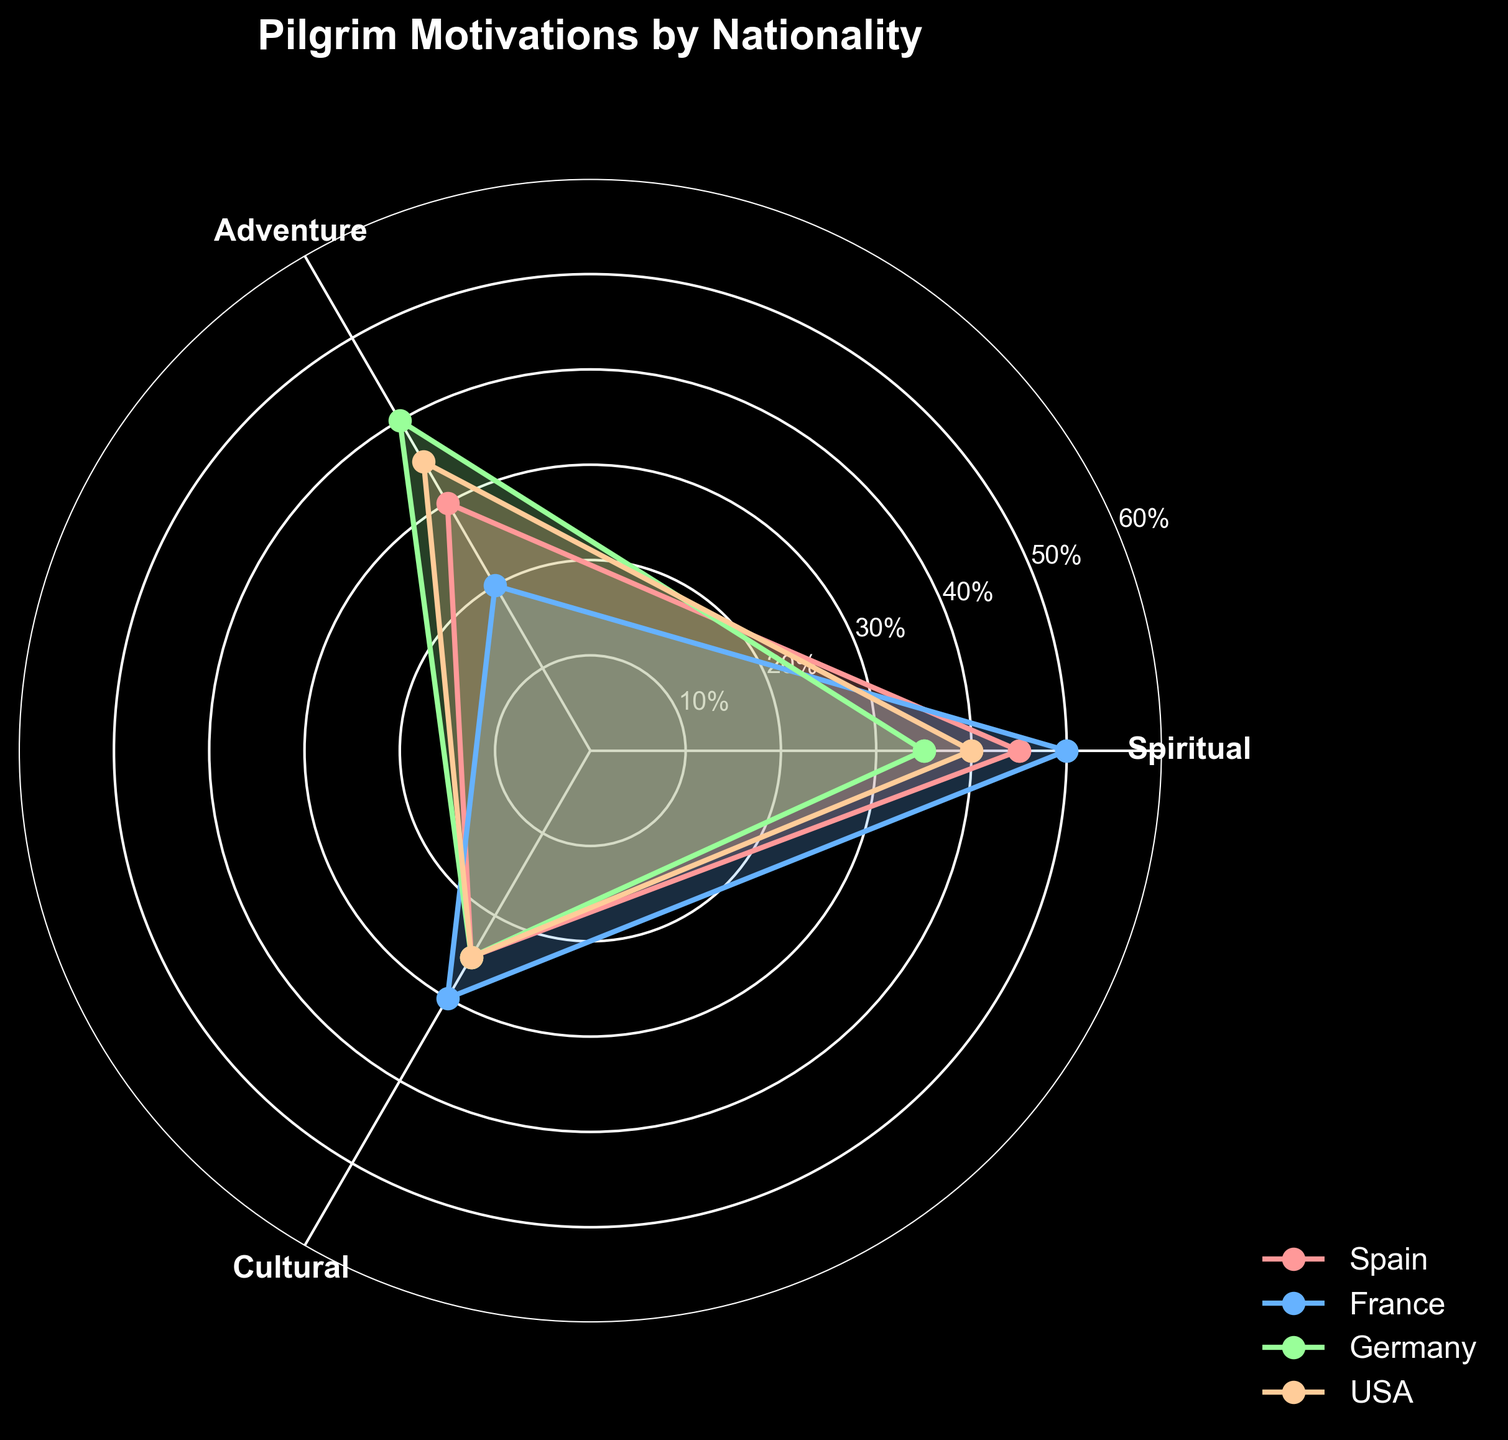What are the three motivations displayed on the radar chart? The three motivations are named in the original data and are visible as axis labels in the figure. They are Spiritual, Adventure, and Cultural.
Answer: Spiritual, Adventure, Cultural Which country has the highest percentage of pilgrims motivated by Spiritual reasons? By examining the radar chart, we can see that the country with the longest line extending towards the 'Spiritual' axis is France. France has a 50% value for the Spiritual motivation, the highest among all countries.
Answer: France Among the motivations, which one has the smallest overall values across all countries? By checking each axis on the radar chart, we can find that the 'Cultural' motivation has the lowest percentages overall compared to Spiritual and Adventure. The values on the 'Cultural' axis are 25%, 30%, 25%, and 25%.
Answer: Cultural Which country's pilgrims have the most diverse set of motivations? To determine which country has the most diverse set of motivations, we look at the radar chart for the one with the most balanced distribution across all axes. Spain’s pilgrims have relatively balanced values for Spiritual (45), Adventure (30), and Cultural (25).
Answer: Spain What is the maximum percentage difference between any two motivations for USA? For USA, the percentages are 40 for Spiritual, 35 for Adventure, and 25 for Cultural. The maximum difference is between Spiritual (40) and Cultural (25), which is 40 - 25 = 15.
Answer: 15 Compare Spain and Germany: Which country has a higher percentage of pilgrims motivated by Adventure? From the radar chart, we see that Germany has a higher percentage for Adventure (40%) compared to Spain (30%).
Answer: Germany If you average the motivations for French pilgrims, what's the value? The values for France are: Spiritual (50), Adventure (20), Cultural (30). The average is calculated as: (50 + 20 + 30) / 3 = 100 / 3 ≈ 33.33.
Answer: 33.33 Which country shows the least interest in Cultural motivation? Looking at the radar chart, all countries have similar values for Cultural motivation except for USA, which has the lowest at 25%. However, since multiple countries (Spain, Germany, USA) share the same lowest value, Germany could equally be acceptable.
Answer: USA How does the USA compare to France in terms of Adventure motivation? From the radar chart, USA has an Adventure value of 35%, while France has a value of 20%. USA's value is higher by 15%.
Answer: USA has 15% more In which motivation do Spanish pilgrims show the most interest? Inspecting Spain's values on the radar chart shows that the highest value for Spain is in the Spiritual motivation, with 45%.
Answer: Spiritual 